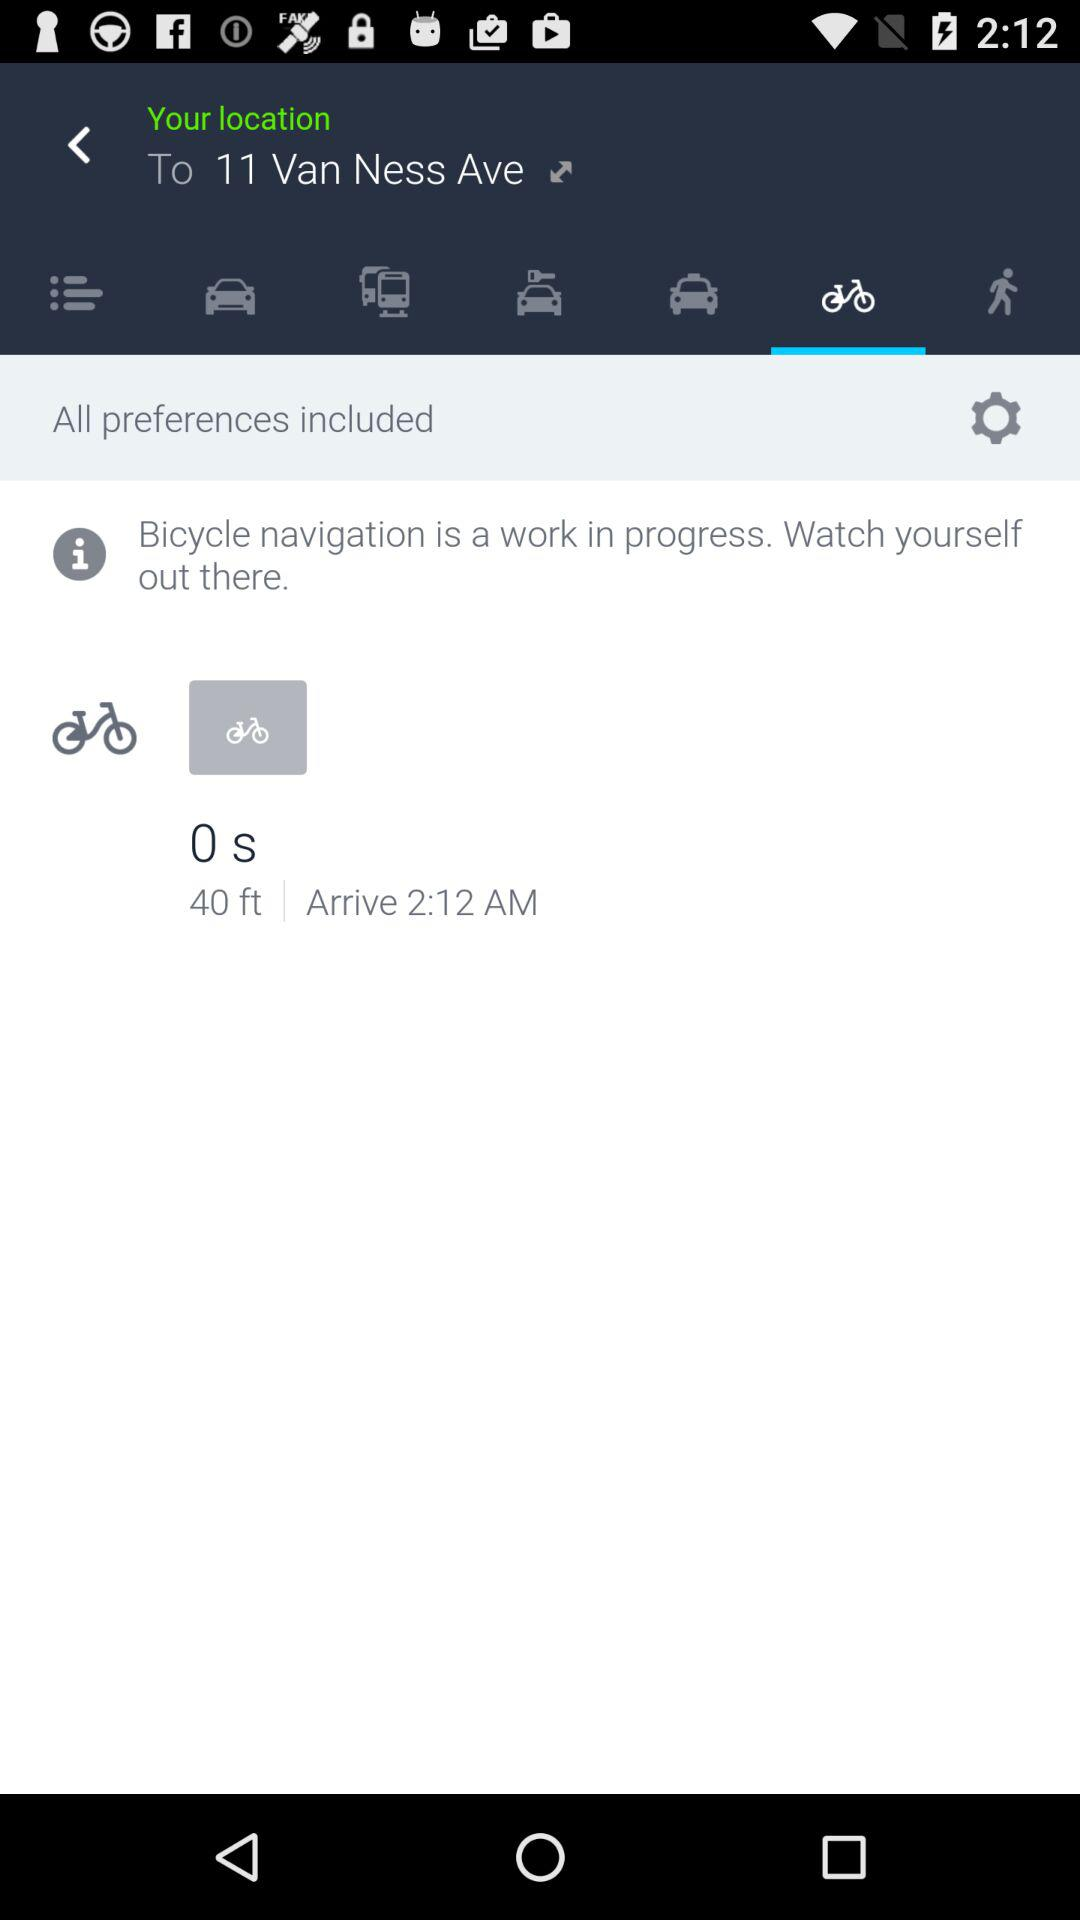How long will it take to get to the destination by bicycle?
Answer the question using a single word or phrase. 0 s 